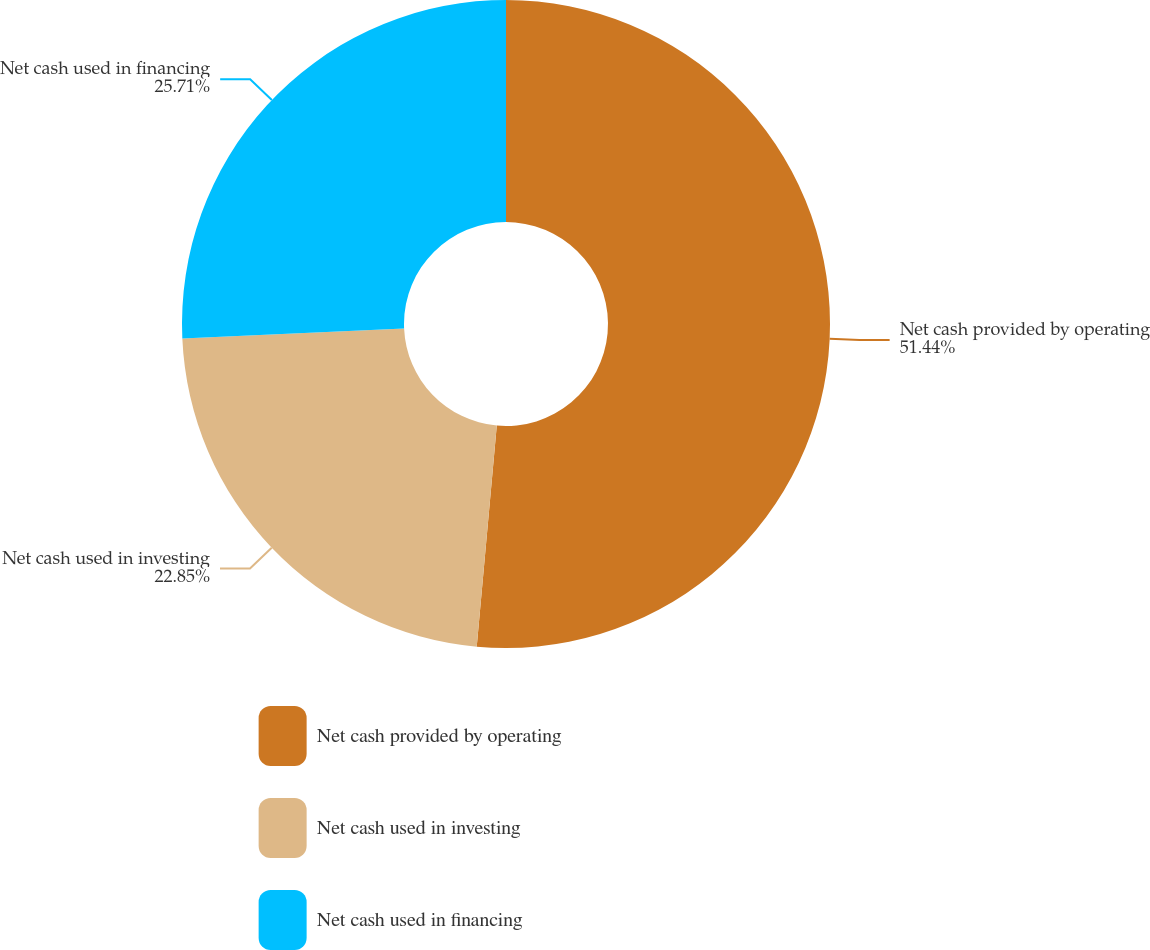Convert chart. <chart><loc_0><loc_0><loc_500><loc_500><pie_chart><fcel>Net cash provided by operating<fcel>Net cash used in investing<fcel>Net cash used in financing<nl><fcel>51.44%<fcel>22.85%<fcel>25.71%<nl></chart> 